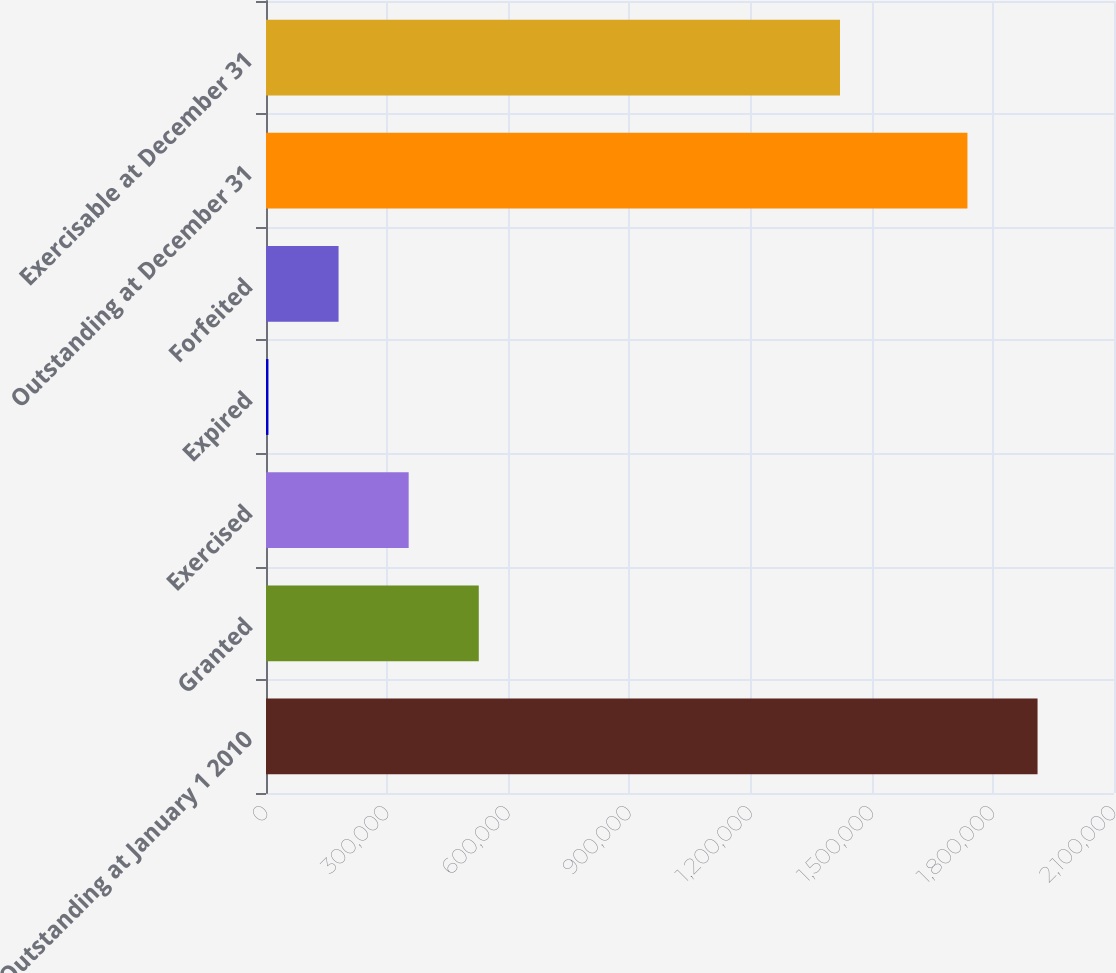Convert chart. <chart><loc_0><loc_0><loc_500><loc_500><bar_chart><fcel>Outstanding at January 1 2010<fcel>Granted<fcel>Exercised<fcel>Expired<fcel>Forfeited<fcel>Outstanding at December 31<fcel>Exercisable at December 31<nl><fcel>1.91068e+06<fcel>526920<fcel>353298<fcel>6053<fcel>179676<fcel>1.73706e+06<fcel>1.42147e+06<nl></chart> 